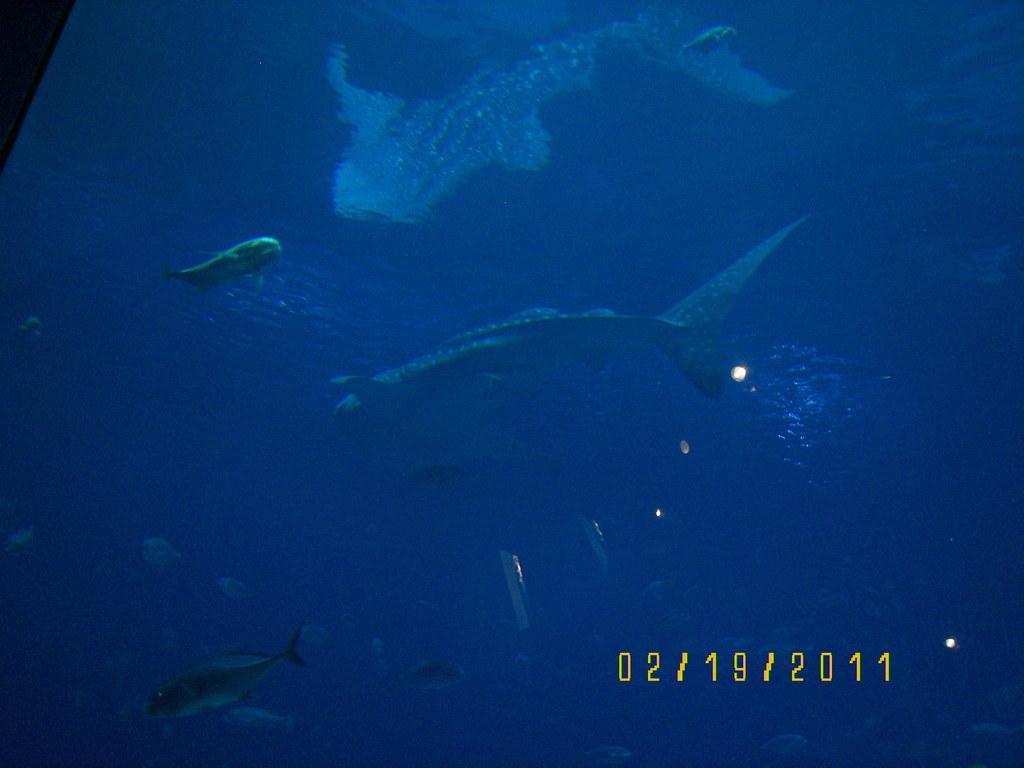Please provide a concise description of this image. This image consists of sharks and fishes in the water. At the bottom, there is a date. 